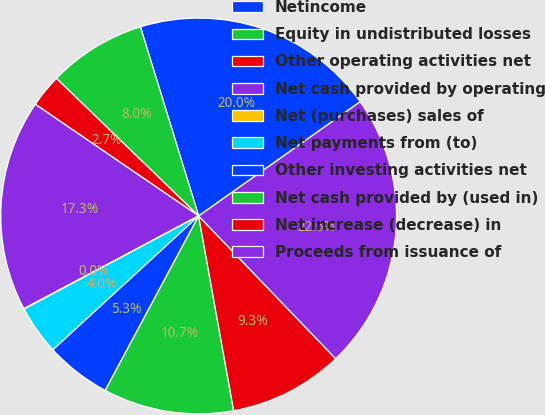Convert chart. <chart><loc_0><loc_0><loc_500><loc_500><pie_chart><fcel>Netincome<fcel>Equity in undistributed losses<fcel>Other operating activities net<fcel>Net cash provided by operating<fcel>Net (purchases) sales of<fcel>Net payments from (to)<fcel>Other investing activities net<fcel>Net cash provided by (used in)<fcel>Net increase (decrease) in<fcel>Proceeds from issuance of<nl><fcel>19.96%<fcel>8.01%<fcel>2.69%<fcel>17.31%<fcel>0.04%<fcel>4.02%<fcel>5.35%<fcel>10.66%<fcel>9.34%<fcel>22.62%<nl></chart> 